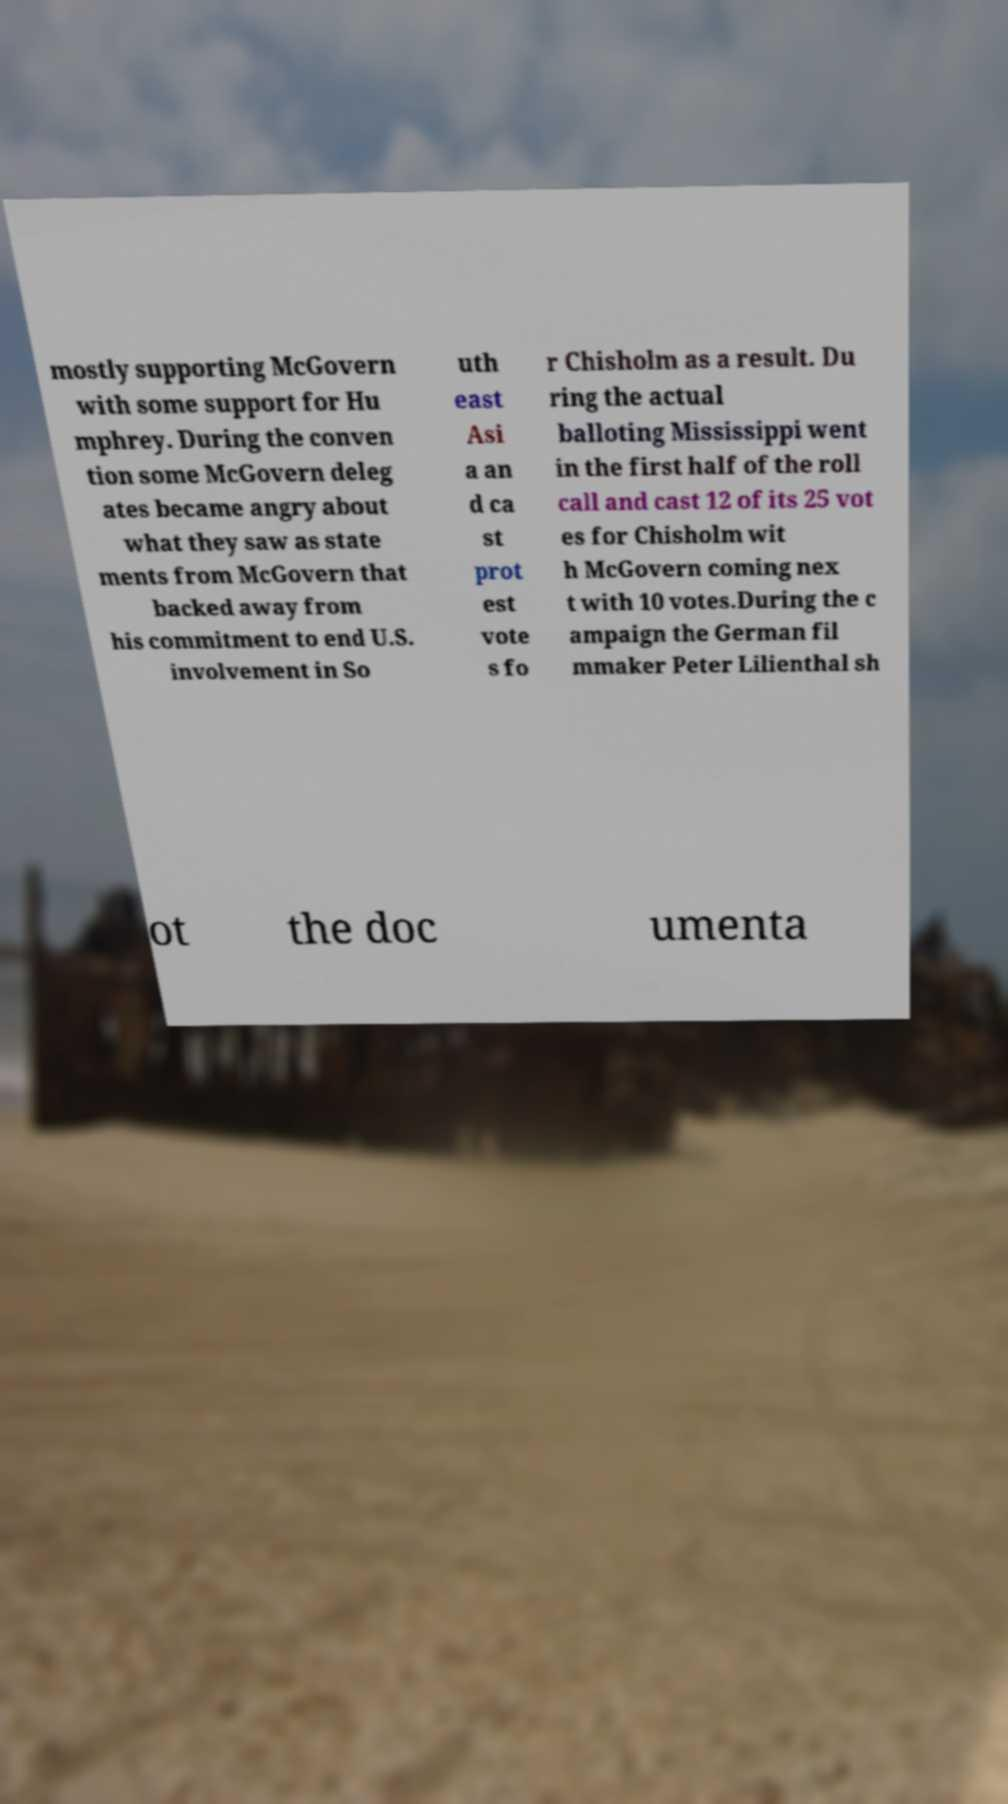Could you assist in decoding the text presented in this image and type it out clearly? mostly supporting McGovern with some support for Hu mphrey. During the conven tion some McGovern deleg ates became angry about what they saw as state ments from McGovern that backed away from his commitment to end U.S. involvement in So uth east Asi a an d ca st prot est vote s fo r Chisholm as a result. Du ring the actual balloting Mississippi went in the first half of the roll call and cast 12 of its 25 vot es for Chisholm wit h McGovern coming nex t with 10 votes.During the c ampaign the German fil mmaker Peter Lilienthal sh ot the doc umenta 